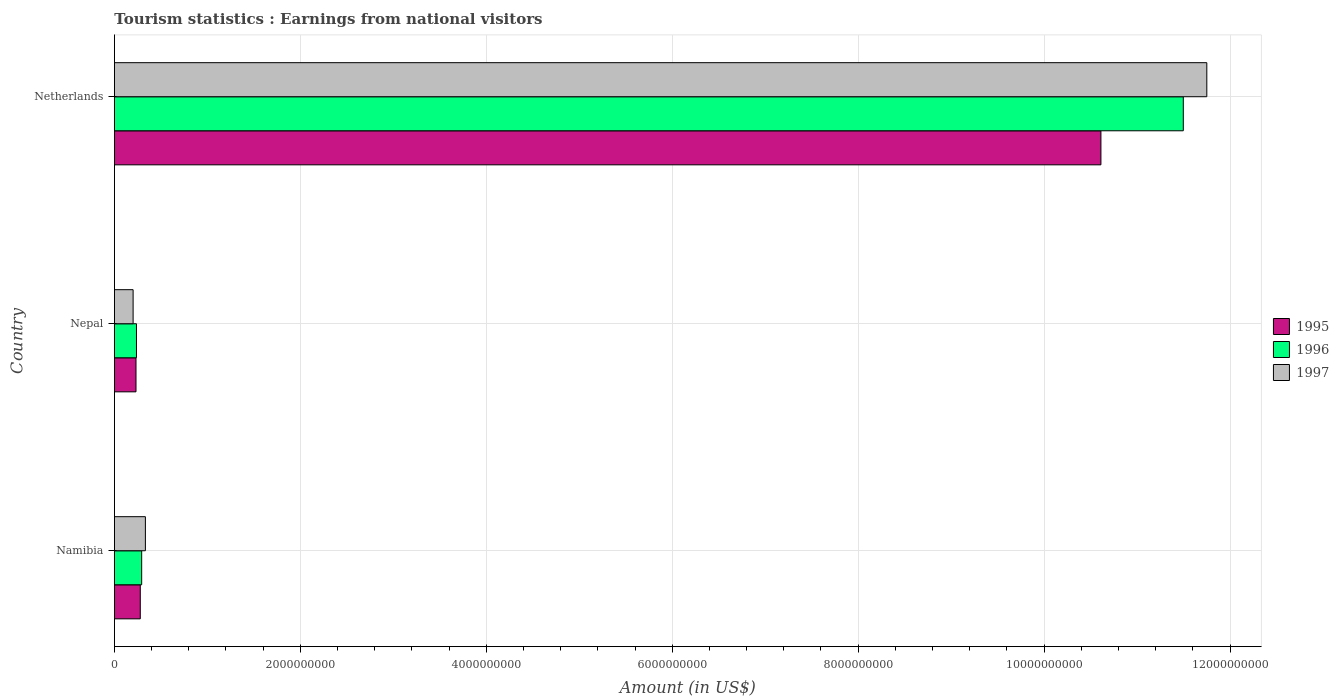Are the number of bars per tick equal to the number of legend labels?
Your answer should be very brief. Yes. How many bars are there on the 2nd tick from the bottom?
Make the answer very short. 3. What is the label of the 2nd group of bars from the top?
Your response must be concise. Nepal. What is the earnings from national visitors in 1996 in Namibia?
Your response must be concise. 2.93e+08. Across all countries, what is the maximum earnings from national visitors in 1997?
Keep it short and to the point. 1.18e+1. Across all countries, what is the minimum earnings from national visitors in 1995?
Your answer should be very brief. 2.32e+08. In which country was the earnings from national visitors in 1995 minimum?
Offer a terse response. Nepal. What is the total earnings from national visitors in 1996 in the graph?
Give a very brief answer. 1.20e+1. What is the difference between the earnings from national visitors in 1997 in Namibia and that in Nepal?
Keep it short and to the point. 1.32e+08. What is the difference between the earnings from national visitors in 1997 in Netherlands and the earnings from national visitors in 1996 in Namibia?
Provide a succinct answer. 1.15e+1. What is the average earnings from national visitors in 1995 per country?
Offer a very short reply. 3.71e+09. What is the difference between the earnings from national visitors in 1996 and earnings from national visitors in 1995 in Namibia?
Make the answer very short. 1.50e+07. In how many countries, is the earnings from national visitors in 1995 greater than 5200000000 US$?
Provide a short and direct response. 1. What is the ratio of the earnings from national visitors in 1995 in Namibia to that in Netherlands?
Offer a terse response. 0.03. Is the earnings from national visitors in 1995 in Namibia less than that in Nepal?
Offer a terse response. No. What is the difference between the highest and the second highest earnings from national visitors in 1997?
Offer a very short reply. 1.14e+1. What is the difference between the highest and the lowest earnings from national visitors in 1996?
Offer a terse response. 1.13e+1. Is the sum of the earnings from national visitors in 1997 in Nepal and Netherlands greater than the maximum earnings from national visitors in 1996 across all countries?
Your answer should be compact. Yes. Are all the bars in the graph horizontal?
Your response must be concise. Yes. Does the graph contain grids?
Provide a succinct answer. Yes. How many legend labels are there?
Ensure brevity in your answer.  3. What is the title of the graph?
Your answer should be compact. Tourism statistics : Earnings from national visitors. What is the label or title of the Y-axis?
Give a very brief answer. Country. What is the Amount (in US$) of 1995 in Namibia?
Offer a very short reply. 2.78e+08. What is the Amount (in US$) in 1996 in Namibia?
Make the answer very short. 2.93e+08. What is the Amount (in US$) of 1997 in Namibia?
Offer a terse response. 3.33e+08. What is the Amount (in US$) in 1995 in Nepal?
Provide a short and direct response. 2.32e+08. What is the Amount (in US$) of 1996 in Nepal?
Offer a very short reply. 2.37e+08. What is the Amount (in US$) in 1997 in Nepal?
Keep it short and to the point. 2.01e+08. What is the Amount (in US$) of 1995 in Netherlands?
Offer a terse response. 1.06e+1. What is the Amount (in US$) in 1996 in Netherlands?
Offer a very short reply. 1.15e+1. What is the Amount (in US$) in 1997 in Netherlands?
Your response must be concise. 1.18e+1. Across all countries, what is the maximum Amount (in US$) of 1995?
Ensure brevity in your answer.  1.06e+1. Across all countries, what is the maximum Amount (in US$) of 1996?
Provide a succinct answer. 1.15e+1. Across all countries, what is the maximum Amount (in US$) in 1997?
Provide a succinct answer. 1.18e+1. Across all countries, what is the minimum Amount (in US$) of 1995?
Your answer should be compact. 2.32e+08. Across all countries, what is the minimum Amount (in US$) of 1996?
Ensure brevity in your answer.  2.37e+08. Across all countries, what is the minimum Amount (in US$) in 1997?
Offer a very short reply. 2.01e+08. What is the total Amount (in US$) in 1995 in the graph?
Give a very brief answer. 1.11e+1. What is the total Amount (in US$) of 1996 in the graph?
Your answer should be compact. 1.20e+1. What is the total Amount (in US$) of 1997 in the graph?
Ensure brevity in your answer.  1.23e+1. What is the difference between the Amount (in US$) of 1995 in Namibia and that in Nepal?
Keep it short and to the point. 4.60e+07. What is the difference between the Amount (in US$) of 1996 in Namibia and that in Nepal?
Your answer should be very brief. 5.60e+07. What is the difference between the Amount (in US$) of 1997 in Namibia and that in Nepal?
Your answer should be very brief. 1.32e+08. What is the difference between the Amount (in US$) in 1995 in Namibia and that in Netherlands?
Your answer should be compact. -1.03e+1. What is the difference between the Amount (in US$) of 1996 in Namibia and that in Netherlands?
Offer a very short reply. -1.12e+1. What is the difference between the Amount (in US$) in 1997 in Namibia and that in Netherlands?
Your response must be concise. -1.14e+1. What is the difference between the Amount (in US$) in 1995 in Nepal and that in Netherlands?
Provide a short and direct response. -1.04e+1. What is the difference between the Amount (in US$) of 1996 in Nepal and that in Netherlands?
Your answer should be very brief. -1.13e+1. What is the difference between the Amount (in US$) of 1997 in Nepal and that in Netherlands?
Give a very brief answer. -1.15e+1. What is the difference between the Amount (in US$) in 1995 in Namibia and the Amount (in US$) in 1996 in Nepal?
Keep it short and to the point. 4.10e+07. What is the difference between the Amount (in US$) in 1995 in Namibia and the Amount (in US$) in 1997 in Nepal?
Your answer should be very brief. 7.70e+07. What is the difference between the Amount (in US$) of 1996 in Namibia and the Amount (in US$) of 1997 in Nepal?
Give a very brief answer. 9.20e+07. What is the difference between the Amount (in US$) in 1995 in Namibia and the Amount (in US$) in 1996 in Netherlands?
Give a very brief answer. -1.12e+1. What is the difference between the Amount (in US$) in 1995 in Namibia and the Amount (in US$) in 1997 in Netherlands?
Your answer should be compact. -1.15e+1. What is the difference between the Amount (in US$) in 1996 in Namibia and the Amount (in US$) in 1997 in Netherlands?
Your response must be concise. -1.15e+1. What is the difference between the Amount (in US$) of 1995 in Nepal and the Amount (in US$) of 1996 in Netherlands?
Make the answer very short. -1.13e+1. What is the difference between the Amount (in US$) in 1995 in Nepal and the Amount (in US$) in 1997 in Netherlands?
Offer a terse response. -1.15e+1. What is the difference between the Amount (in US$) of 1996 in Nepal and the Amount (in US$) of 1997 in Netherlands?
Your response must be concise. -1.15e+1. What is the average Amount (in US$) of 1995 per country?
Make the answer very short. 3.71e+09. What is the average Amount (in US$) in 1996 per country?
Offer a terse response. 4.01e+09. What is the average Amount (in US$) in 1997 per country?
Your answer should be very brief. 4.09e+09. What is the difference between the Amount (in US$) of 1995 and Amount (in US$) of 1996 in Namibia?
Give a very brief answer. -1.50e+07. What is the difference between the Amount (in US$) of 1995 and Amount (in US$) of 1997 in Namibia?
Make the answer very short. -5.50e+07. What is the difference between the Amount (in US$) of 1996 and Amount (in US$) of 1997 in Namibia?
Your answer should be compact. -4.00e+07. What is the difference between the Amount (in US$) of 1995 and Amount (in US$) of 1996 in Nepal?
Give a very brief answer. -5.00e+06. What is the difference between the Amount (in US$) of 1995 and Amount (in US$) of 1997 in Nepal?
Offer a very short reply. 3.10e+07. What is the difference between the Amount (in US$) in 1996 and Amount (in US$) in 1997 in Nepal?
Keep it short and to the point. 3.60e+07. What is the difference between the Amount (in US$) in 1995 and Amount (in US$) in 1996 in Netherlands?
Offer a very short reply. -8.86e+08. What is the difference between the Amount (in US$) of 1995 and Amount (in US$) of 1997 in Netherlands?
Provide a short and direct response. -1.14e+09. What is the difference between the Amount (in US$) in 1996 and Amount (in US$) in 1997 in Netherlands?
Your answer should be compact. -2.53e+08. What is the ratio of the Amount (in US$) in 1995 in Namibia to that in Nepal?
Ensure brevity in your answer.  1.2. What is the ratio of the Amount (in US$) of 1996 in Namibia to that in Nepal?
Offer a very short reply. 1.24. What is the ratio of the Amount (in US$) in 1997 in Namibia to that in Nepal?
Offer a very short reply. 1.66. What is the ratio of the Amount (in US$) of 1995 in Namibia to that in Netherlands?
Your answer should be very brief. 0.03. What is the ratio of the Amount (in US$) in 1996 in Namibia to that in Netherlands?
Offer a very short reply. 0.03. What is the ratio of the Amount (in US$) in 1997 in Namibia to that in Netherlands?
Keep it short and to the point. 0.03. What is the ratio of the Amount (in US$) in 1995 in Nepal to that in Netherlands?
Provide a succinct answer. 0.02. What is the ratio of the Amount (in US$) of 1996 in Nepal to that in Netherlands?
Offer a very short reply. 0.02. What is the ratio of the Amount (in US$) in 1997 in Nepal to that in Netherlands?
Your response must be concise. 0.02. What is the difference between the highest and the second highest Amount (in US$) in 1995?
Ensure brevity in your answer.  1.03e+1. What is the difference between the highest and the second highest Amount (in US$) in 1996?
Your response must be concise. 1.12e+1. What is the difference between the highest and the second highest Amount (in US$) of 1997?
Your answer should be compact. 1.14e+1. What is the difference between the highest and the lowest Amount (in US$) of 1995?
Offer a very short reply. 1.04e+1. What is the difference between the highest and the lowest Amount (in US$) of 1996?
Offer a very short reply. 1.13e+1. What is the difference between the highest and the lowest Amount (in US$) in 1997?
Provide a succinct answer. 1.15e+1. 